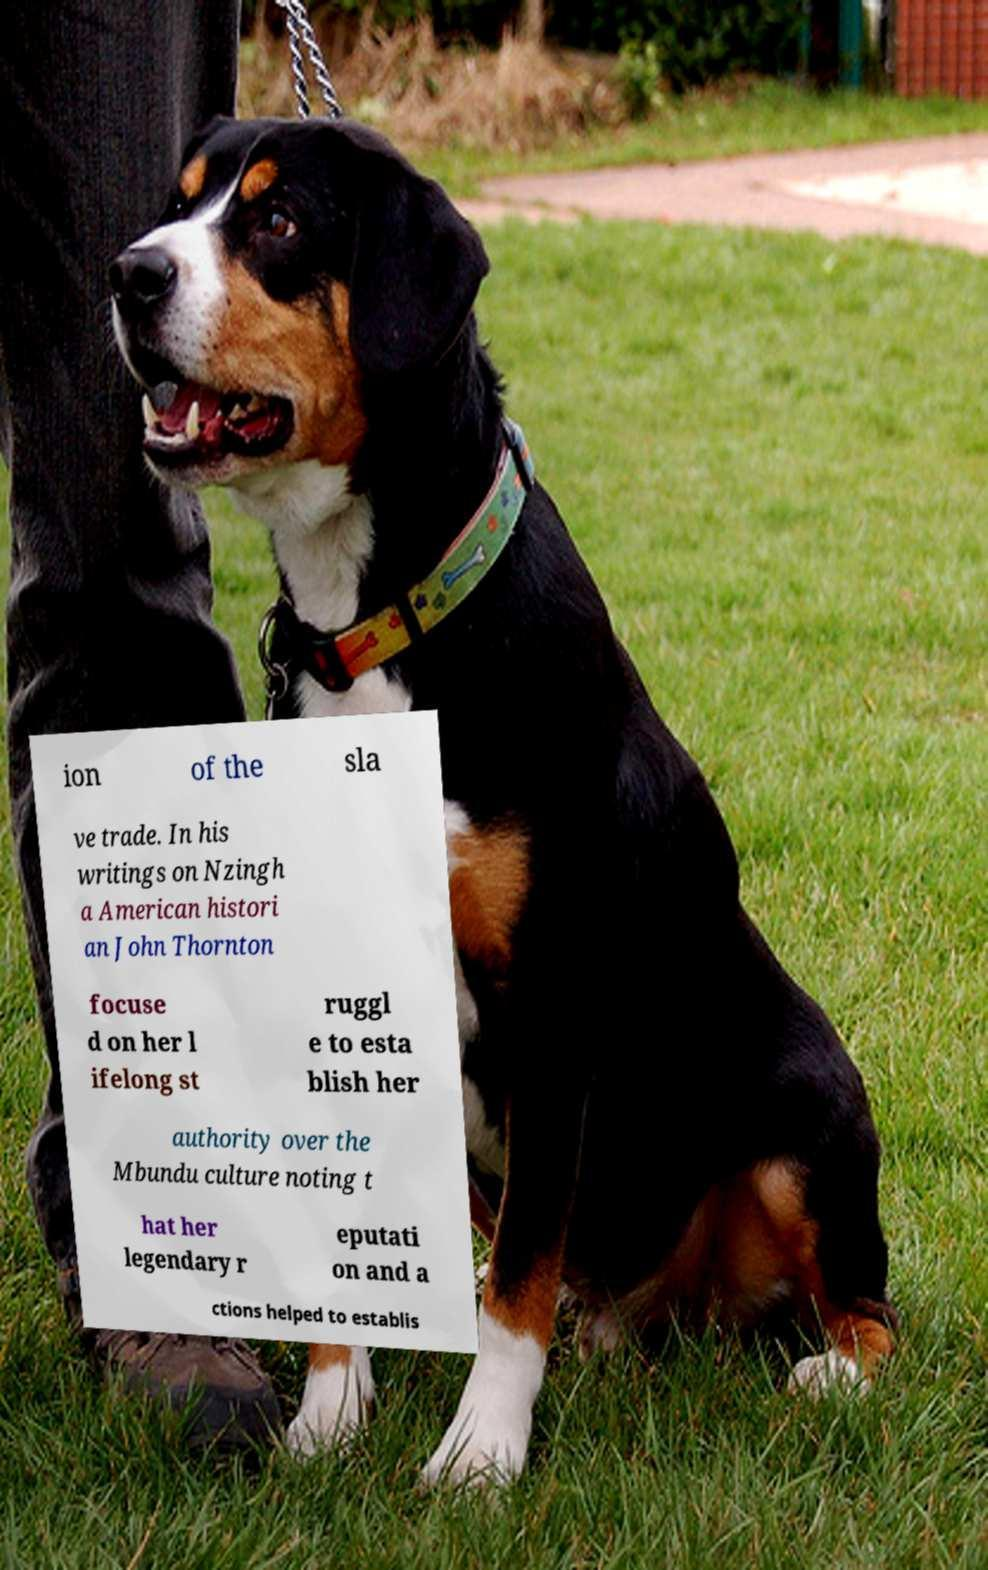Can you accurately transcribe the text from the provided image for me? ion of the sla ve trade. In his writings on Nzingh a American histori an John Thornton focuse d on her l ifelong st ruggl e to esta blish her authority over the Mbundu culture noting t hat her legendary r eputati on and a ctions helped to establis 